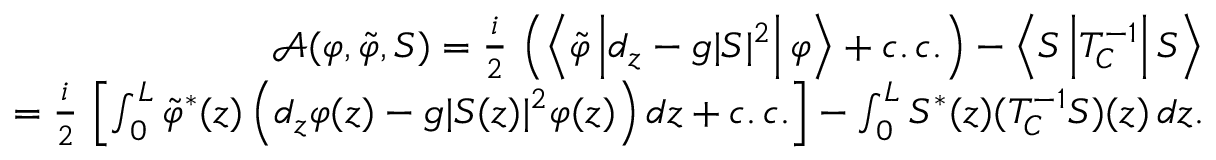Convert formula to latex. <formula><loc_0><loc_0><loc_500><loc_500>\begin{array} { r l r } & { \mathcal { A } ( \varphi , \tilde { \varphi } , S ) = \frac { i } { 2 } \, \left ( \left \langle \tilde { \varphi } \left | d _ { z } - g | S | ^ { 2 } \right | \varphi \right \rangle + c . \, c . \right ) - \left \langle S \left | T _ { C } ^ { - 1 } \right | S \right \rangle } \\ & { = \frac { i } { 2 } \, \left [ \int _ { 0 } ^ { L } \tilde { \varphi } ^ { \ast } ( z ) \left ( d _ { z } \varphi ( z ) - g | S ( z ) | ^ { 2 } \varphi ( z ) \right ) d z + c . \, c . \right ] - \int _ { 0 } ^ { L } S ^ { \ast } ( z ) ( T _ { C } ^ { - 1 } S ) ( z ) \, d z . } \end{array}</formula> 